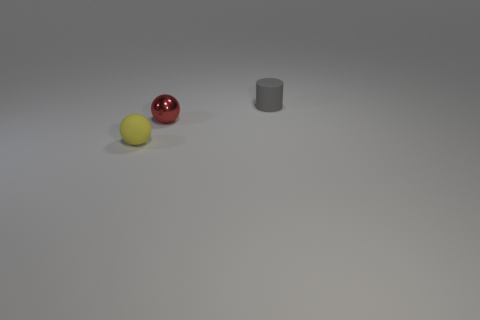Add 1 metal objects. How many objects exist? 4 Subtract all red spheres. How many spheres are left? 1 Subtract 0 cyan cubes. How many objects are left? 3 Subtract all cylinders. How many objects are left? 2 Subtract 1 spheres. How many spheres are left? 1 Subtract all green balls. Subtract all yellow blocks. How many balls are left? 2 Subtract all cyan spheres. How many yellow cylinders are left? 0 Subtract all tiny blue rubber objects. Subtract all tiny gray objects. How many objects are left? 2 Add 1 small gray rubber things. How many small gray rubber things are left? 2 Add 1 big purple cubes. How many big purple cubes exist? 1 